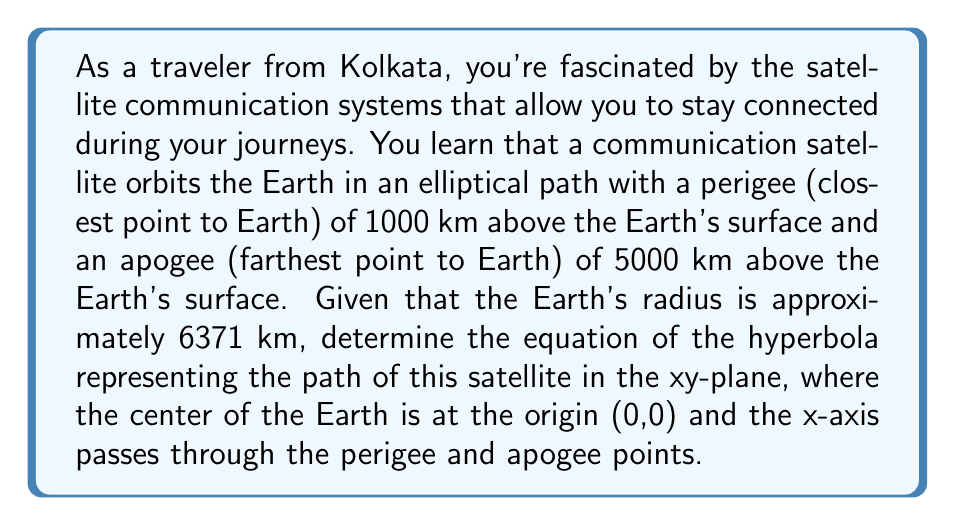What is the answer to this math problem? Let's approach this step-by-step:

1) First, we need to identify the center of the hyperbola. It will be halfway between the perigee and apogee:
   
   Center = $\frac{(6371 + 1000) + (6371 + 5000)}{2} = 9371$ km from Earth's center

2) The transverse axis of the hyperbola will be along the x-axis. We can calculate its length:
   
   Transverse axis = $(6371 + 5000) - (6371 + 1000) = 4000$ km

3) The focal point of the hyperbola is at the center of the Earth (0,0). The distance from the center of the hyperbola to the focal point is:
   
   $c = 9371$ km

4) We can now calculate $a$ (half of the transverse axis):
   
   $a = \frac{4000}{2} = 2000$ km

5) Using the relation $c^2 = a^2 + b^2$ for a hyperbola, we can find $b$:
   
   $b^2 = c^2 - a^2 = 9371^2 - 2000^2 = 83816641$
   $b = \sqrt{83816641} \approx 9155.15$ km

6) The standard form of a hyperbola with center $(h,k)$ is:
   
   $\frac{(x-h)^2}{a^2} - \frac{(y-k)^2}{b^2} = 1$

7) Substituting our values:

   $\frac{(x-9371)^2}{2000^2} - \frac{y^2}{9155.15^2} = 1$

8) Simplifying:

   $\frac{(x-9371)^2}{4000000} - \frac{y^2}{83816641} = 1$
Answer: $\frac{(x-9371)^2}{4000000} - \frac{y^2}{83816641} = 1$ 